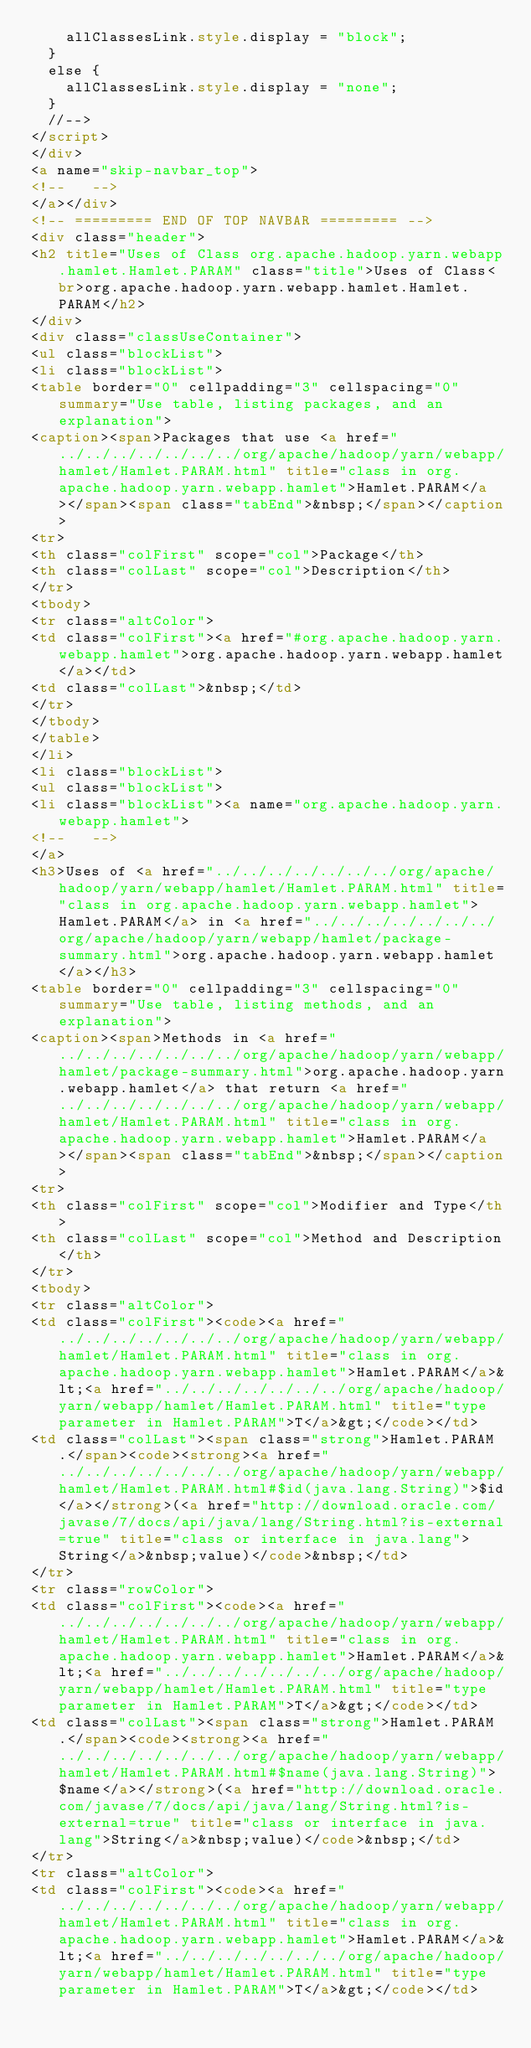<code> <loc_0><loc_0><loc_500><loc_500><_HTML_>    allClassesLink.style.display = "block";
  }
  else {
    allClassesLink.style.display = "none";
  }
  //-->
</script>
</div>
<a name="skip-navbar_top">
<!--   -->
</a></div>
<!-- ========= END OF TOP NAVBAR ========= -->
<div class="header">
<h2 title="Uses of Class org.apache.hadoop.yarn.webapp.hamlet.Hamlet.PARAM" class="title">Uses of Class<br>org.apache.hadoop.yarn.webapp.hamlet.Hamlet.PARAM</h2>
</div>
<div class="classUseContainer">
<ul class="blockList">
<li class="blockList">
<table border="0" cellpadding="3" cellspacing="0" summary="Use table, listing packages, and an explanation">
<caption><span>Packages that use <a href="../../../../../../../org/apache/hadoop/yarn/webapp/hamlet/Hamlet.PARAM.html" title="class in org.apache.hadoop.yarn.webapp.hamlet">Hamlet.PARAM</a></span><span class="tabEnd">&nbsp;</span></caption>
<tr>
<th class="colFirst" scope="col">Package</th>
<th class="colLast" scope="col">Description</th>
</tr>
<tbody>
<tr class="altColor">
<td class="colFirst"><a href="#org.apache.hadoop.yarn.webapp.hamlet">org.apache.hadoop.yarn.webapp.hamlet</a></td>
<td class="colLast">&nbsp;</td>
</tr>
</tbody>
</table>
</li>
<li class="blockList">
<ul class="blockList">
<li class="blockList"><a name="org.apache.hadoop.yarn.webapp.hamlet">
<!--   -->
</a>
<h3>Uses of <a href="../../../../../../../org/apache/hadoop/yarn/webapp/hamlet/Hamlet.PARAM.html" title="class in org.apache.hadoop.yarn.webapp.hamlet">Hamlet.PARAM</a> in <a href="../../../../../../../org/apache/hadoop/yarn/webapp/hamlet/package-summary.html">org.apache.hadoop.yarn.webapp.hamlet</a></h3>
<table border="0" cellpadding="3" cellspacing="0" summary="Use table, listing methods, and an explanation">
<caption><span>Methods in <a href="../../../../../../../org/apache/hadoop/yarn/webapp/hamlet/package-summary.html">org.apache.hadoop.yarn.webapp.hamlet</a> that return <a href="../../../../../../../org/apache/hadoop/yarn/webapp/hamlet/Hamlet.PARAM.html" title="class in org.apache.hadoop.yarn.webapp.hamlet">Hamlet.PARAM</a></span><span class="tabEnd">&nbsp;</span></caption>
<tr>
<th class="colFirst" scope="col">Modifier and Type</th>
<th class="colLast" scope="col">Method and Description</th>
</tr>
<tbody>
<tr class="altColor">
<td class="colFirst"><code><a href="../../../../../../../org/apache/hadoop/yarn/webapp/hamlet/Hamlet.PARAM.html" title="class in org.apache.hadoop.yarn.webapp.hamlet">Hamlet.PARAM</a>&lt;<a href="../../../../../../../org/apache/hadoop/yarn/webapp/hamlet/Hamlet.PARAM.html" title="type parameter in Hamlet.PARAM">T</a>&gt;</code></td>
<td class="colLast"><span class="strong">Hamlet.PARAM.</span><code><strong><a href="../../../../../../../org/apache/hadoop/yarn/webapp/hamlet/Hamlet.PARAM.html#$id(java.lang.String)">$id</a></strong>(<a href="http://download.oracle.com/javase/7/docs/api/java/lang/String.html?is-external=true" title="class or interface in java.lang">String</a>&nbsp;value)</code>&nbsp;</td>
</tr>
<tr class="rowColor">
<td class="colFirst"><code><a href="../../../../../../../org/apache/hadoop/yarn/webapp/hamlet/Hamlet.PARAM.html" title="class in org.apache.hadoop.yarn.webapp.hamlet">Hamlet.PARAM</a>&lt;<a href="../../../../../../../org/apache/hadoop/yarn/webapp/hamlet/Hamlet.PARAM.html" title="type parameter in Hamlet.PARAM">T</a>&gt;</code></td>
<td class="colLast"><span class="strong">Hamlet.PARAM.</span><code><strong><a href="../../../../../../../org/apache/hadoop/yarn/webapp/hamlet/Hamlet.PARAM.html#$name(java.lang.String)">$name</a></strong>(<a href="http://download.oracle.com/javase/7/docs/api/java/lang/String.html?is-external=true" title="class or interface in java.lang">String</a>&nbsp;value)</code>&nbsp;</td>
</tr>
<tr class="altColor">
<td class="colFirst"><code><a href="../../../../../../../org/apache/hadoop/yarn/webapp/hamlet/Hamlet.PARAM.html" title="class in org.apache.hadoop.yarn.webapp.hamlet">Hamlet.PARAM</a>&lt;<a href="../../../../../../../org/apache/hadoop/yarn/webapp/hamlet/Hamlet.PARAM.html" title="type parameter in Hamlet.PARAM">T</a>&gt;</code></td></code> 